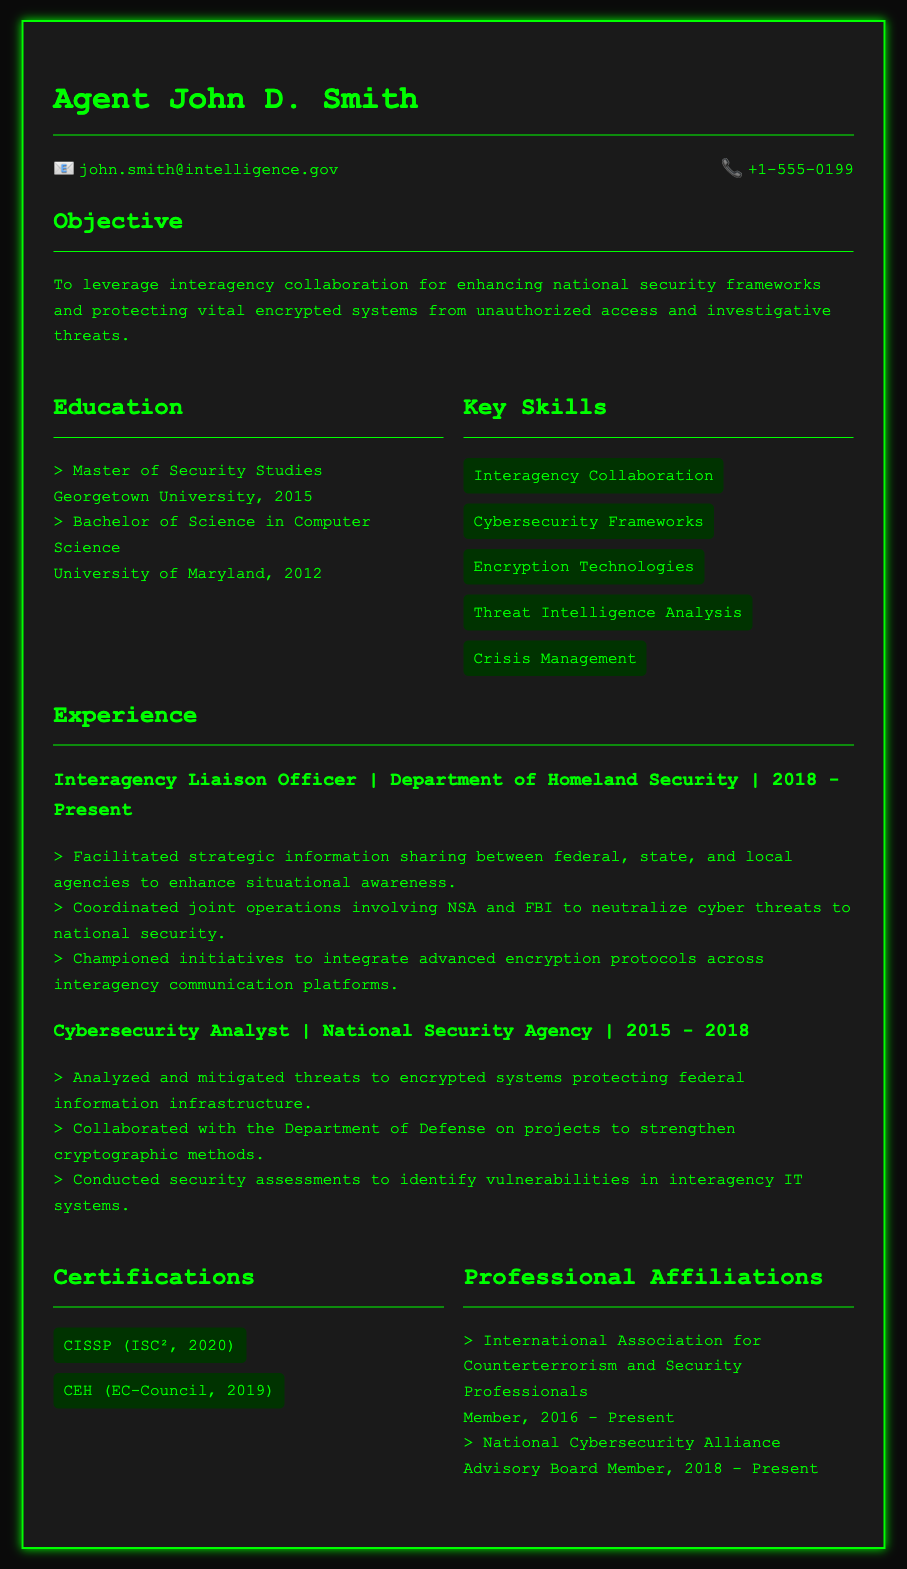what is the name of the agent? The name of the agent is provided in the document header section.
Answer: Agent John D. Smith what is the email address listed in the contact information? The email address for contact is mentioned in the contact section of the document.
Answer: john.smith@intelligence.gov what degree did the agent obtain from Georgetown University? The degree attained from Georgetown University is stated under the education section.
Answer: Master of Security Studies in which year did the agent start working as an Interagency Liaison Officer? The starting year for the role of Interagency Liaison Officer is mentioned in the experience section.
Answer: 2018 how many certifications does the agent have listed? The number of certifications is a count of the items present in the certifications section.
Answer: 2 what agency did the agent work for before the Department of Homeland Security? The agency prior to the current position is indicated in the experience section.
Answer: National Security Agency which skills are highlighted in the CV? Key skills are listed in the document, providing an overview of competencies.
Answer: Interagency Collaboration, Cybersecurity Frameworks, Encryption Technologies, Threat Intelligence Analysis, Crisis Management who is the advisory board member for the National Cybersecurity Alliance? The document states specific roles within professional affiliations, including advisory board member.
Answer: Agent John D. Smith what is the main objective stated in the CV? The objective outlines the agent's professional aspirations and intentions.
Answer: To leverage interagency collaboration for enhancing national security frameworks and protecting vital encrypted systems from unauthorized access and investigative threats 